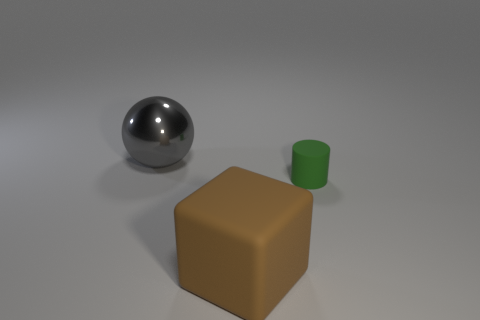Imagine these objects had symbolic meaning, what could they represent? In a symbolic sense, the sphere could represent wholeness or infinity, since it has no beginning or end. The brown block might symbolize stability or foundation, due to its solid and grounded appearance. The green cylinder could stand for growth or the 'out of the box' concept, given its color and distinct shape. 